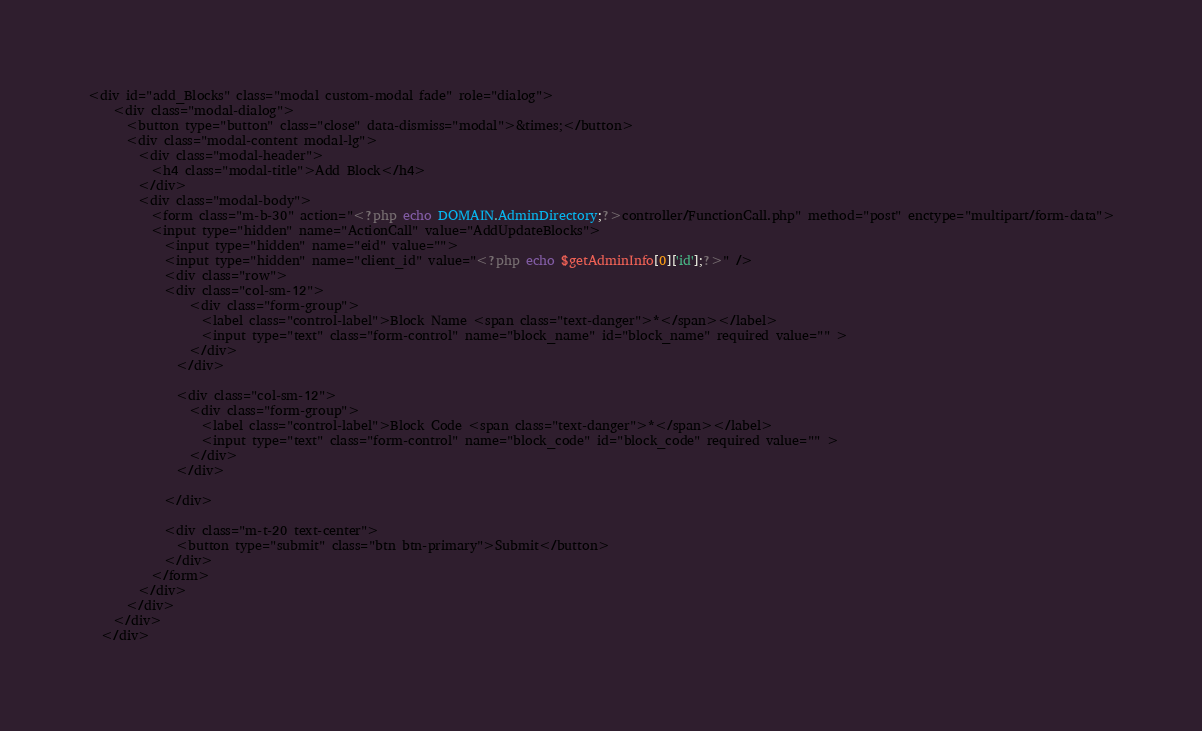Convert code to text. <code><loc_0><loc_0><loc_500><loc_500><_PHP_><div id="add_Blocks" class="modal custom-modal fade" role="dialog">
    <div class="modal-dialog">
      <button type="button" class="close" data-dismiss="modal">&times;</button>
      <div class="modal-content modal-lg">
        <div class="modal-header">
          <h4 class="modal-title">Add Block</h4>
        </div>
        <div class="modal-body">
          <form class="m-b-30" action="<?php echo DOMAIN.AdminDirectory;?>controller/FunctionCall.php" method="post" enctype="multipart/form-data">
          <input type="hidden" name="ActionCall" value="AddUpdateBlocks">
            <input type="hidden" name="eid" value="">
            <input type="hidden" name="client_id" value="<?php echo $getAdminInfo[0]['id'];?>" />
            <div class="row">
            <div class="col-sm-12">
                <div class="form-group">
                  <label class="control-label">Block Name <span class="text-danger">*</span></label>
                  <input type="text" class="form-control" name="block_name" id="block_name" required value="" >
                </div>
              </div>
              
              <div class="col-sm-12">
                <div class="form-group">
                  <label class="control-label">Block Code <span class="text-danger">*</span></label>
                  <input type="text" class="form-control" name="block_code" id="block_code" required value="" >
                </div>
              </div>
              
            </div>
            
            <div class="m-t-20 text-center">
              <button type="submit" class="btn btn-primary">Submit</button>
            </div>
          </form>
        </div>
      </div>
    </div>
  </div></code> 